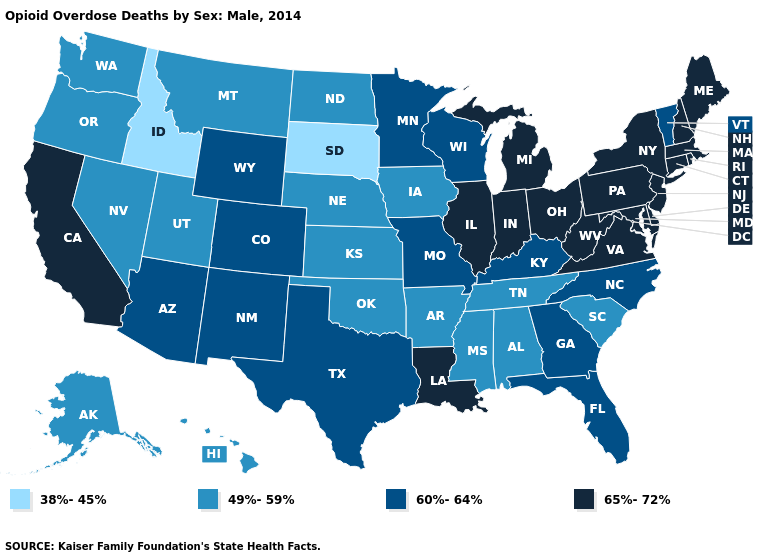How many symbols are there in the legend?
Keep it brief. 4. What is the highest value in states that border Rhode Island?
Quick response, please. 65%-72%. What is the value of California?
Answer briefly. 65%-72%. What is the highest value in the MidWest ?
Write a very short answer. 65%-72%. Does Washington have the highest value in the West?
Write a very short answer. No. Name the states that have a value in the range 65%-72%?
Concise answer only. California, Connecticut, Delaware, Illinois, Indiana, Louisiana, Maine, Maryland, Massachusetts, Michigan, New Hampshire, New Jersey, New York, Ohio, Pennsylvania, Rhode Island, Virginia, West Virginia. What is the value of Oklahoma?
Be succinct. 49%-59%. Name the states that have a value in the range 49%-59%?
Write a very short answer. Alabama, Alaska, Arkansas, Hawaii, Iowa, Kansas, Mississippi, Montana, Nebraska, Nevada, North Dakota, Oklahoma, Oregon, South Carolina, Tennessee, Utah, Washington. Among the states that border Colorado , does Nebraska have the highest value?
Quick response, please. No. Among the states that border Pennsylvania , which have the lowest value?
Answer briefly. Delaware, Maryland, New Jersey, New York, Ohio, West Virginia. What is the lowest value in the USA?
Short answer required. 38%-45%. Does South Dakota have the lowest value in the USA?
Be succinct. Yes. Which states hav the highest value in the MidWest?
Short answer required. Illinois, Indiana, Michigan, Ohio. Which states hav the highest value in the South?
Write a very short answer. Delaware, Louisiana, Maryland, Virginia, West Virginia. What is the lowest value in states that border Oregon?
Keep it brief. 38%-45%. 